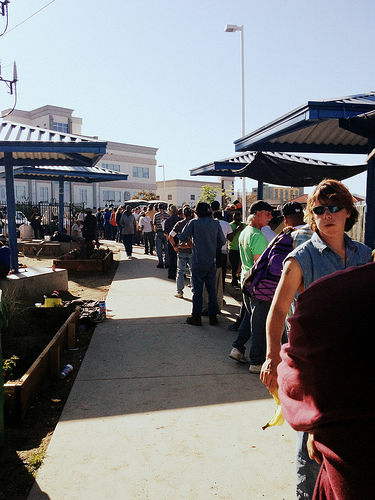<image>
Is there a road next to the people? No. The road is not positioned next to the people. They are located in different areas of the scene. 